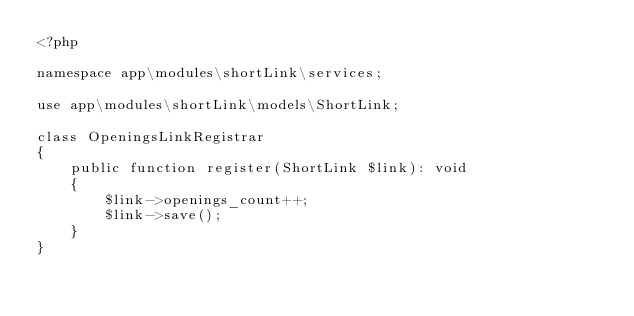<code> <loc_0><loc_0><loc_500><loc_500><_PHP_><?php

namespace app\modules\shortLink\services;

use app\modules\shortLink\models\ShortLink;

class OpeningsLinkRegistrar
{
    public function register(ShortLink $link): void
    {
        $link->openings_count++;
        $link->save();
    }
}
</code> 